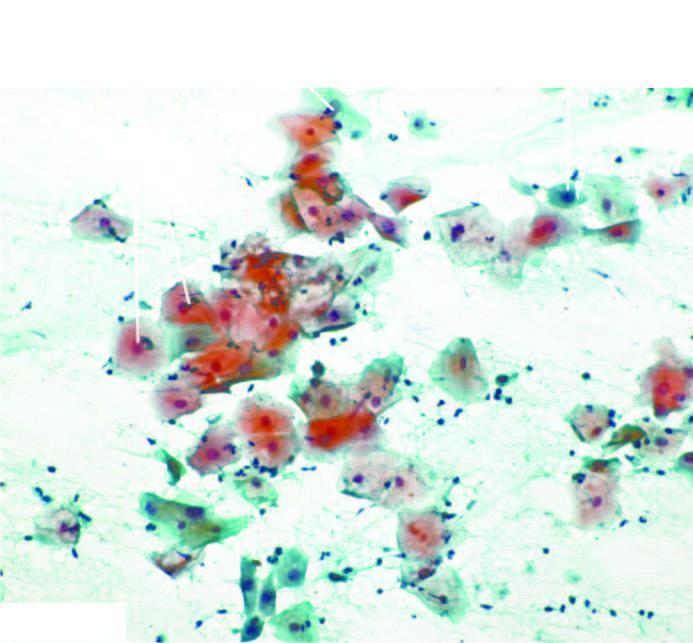s periodic acid schiff seen in normal pap smear?
Answer the question using a single word or phrase. No 